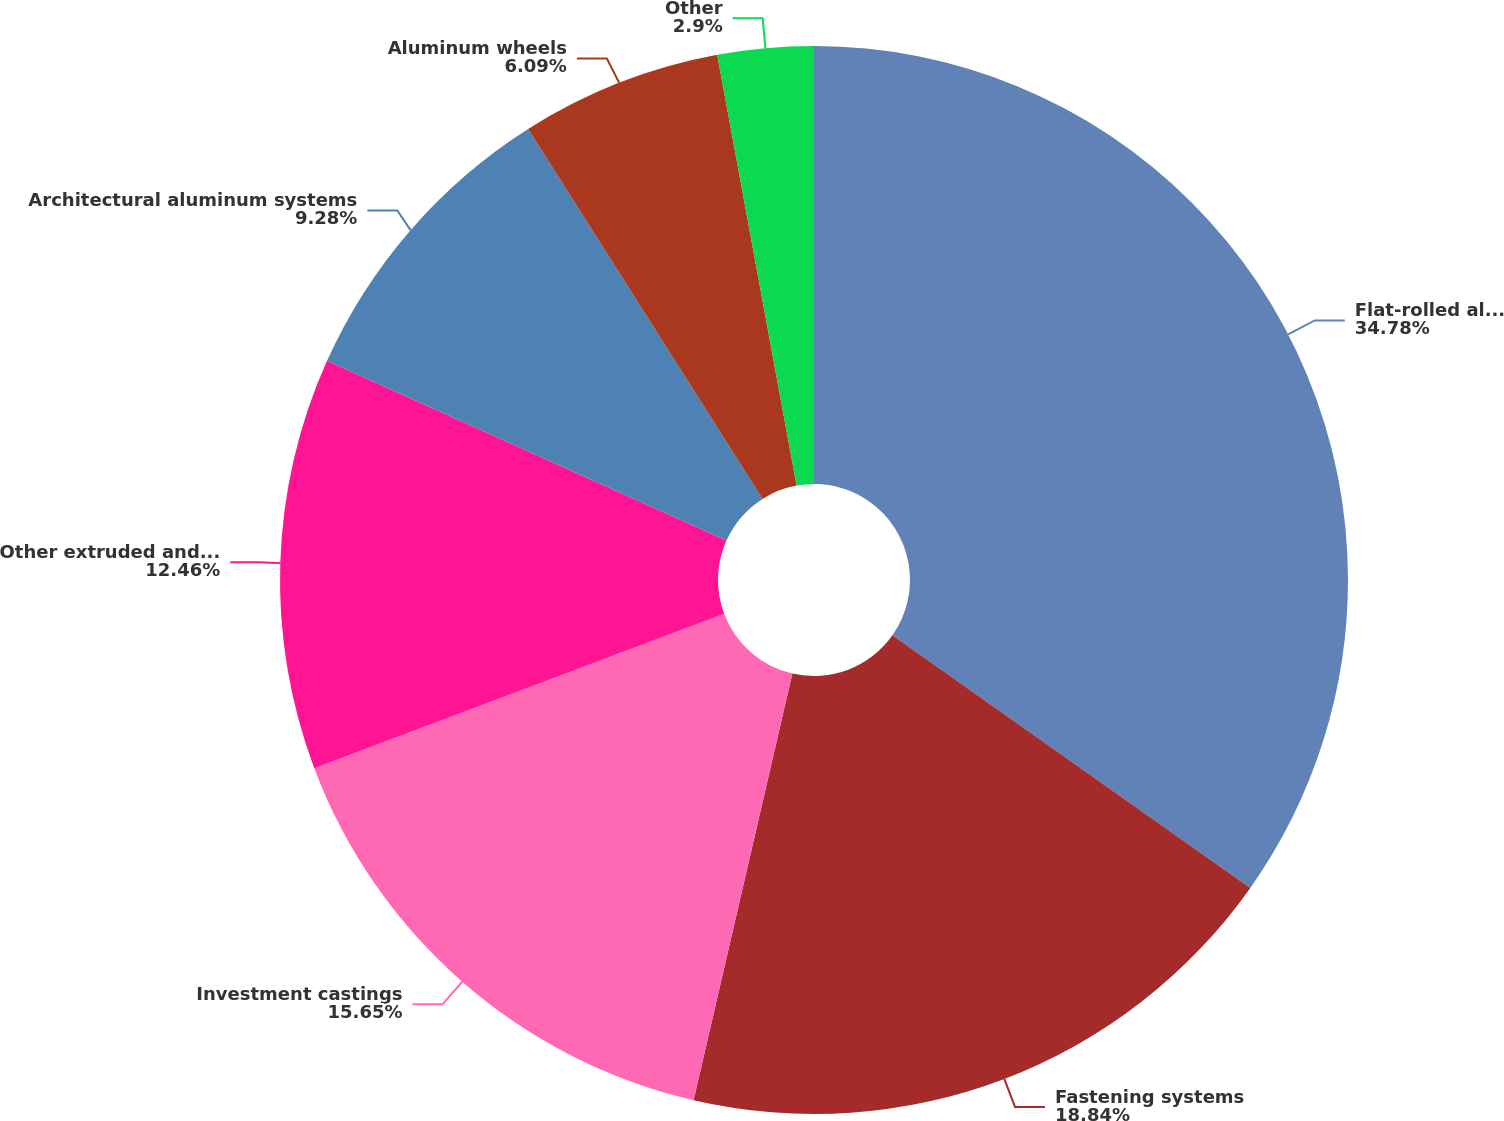<chart> <loc_0><loc_0><loc_500><loc_500><pie_chart><fcel>Flat-rolled aluminum<fcel>Fastening systems<fcel>Investment castings<fcel>Other extruded and forged<fcel>Architectural aluminum systems<fcel>Aluminum wheels<fcel>Other<nl><fcel>34.78%<fcel>18.84%<fcel>15.65%<fcel>12.46%<fcel>9.28%<fcel>6.09%<fcel>2.9%<nl></chart> 